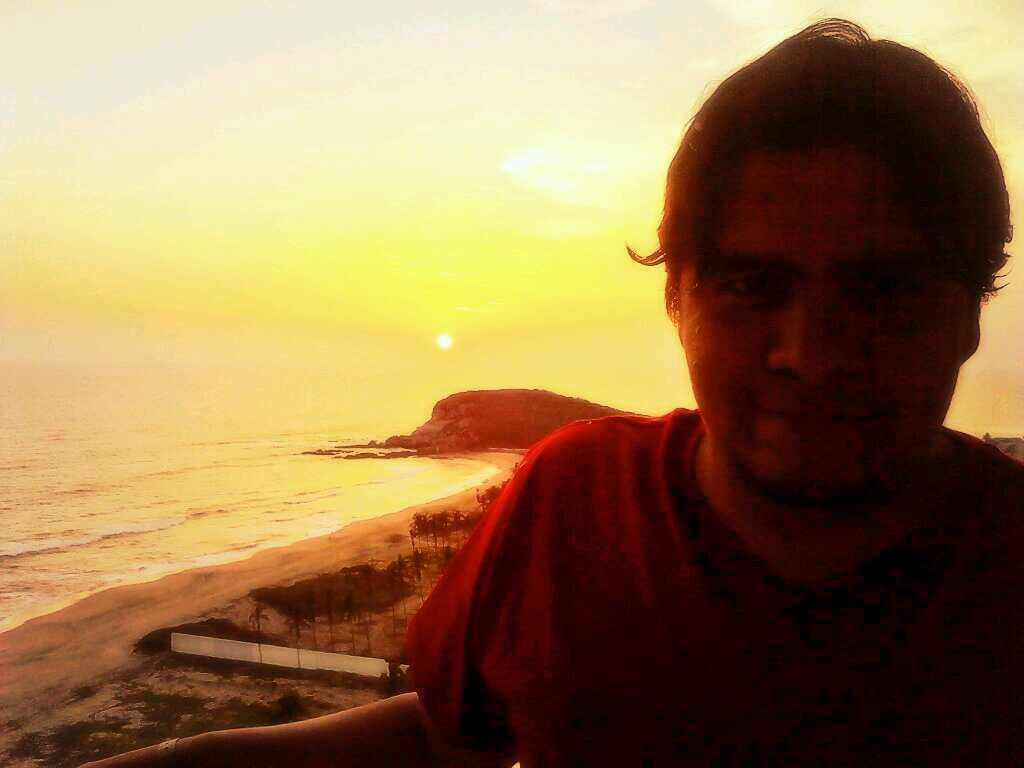Who is present in the image? There is a man in the image. What can be seen in the background of the image? Sky, the sun, a hill, sea, and trees on the sea shore are visible in the background of the image. What type of window can be seen in the image? There is no window present in the image. What is the man pointing at in the image? The provided facts do not mention the man pointing at anything, so we cannot determine what he might be pointing at. 